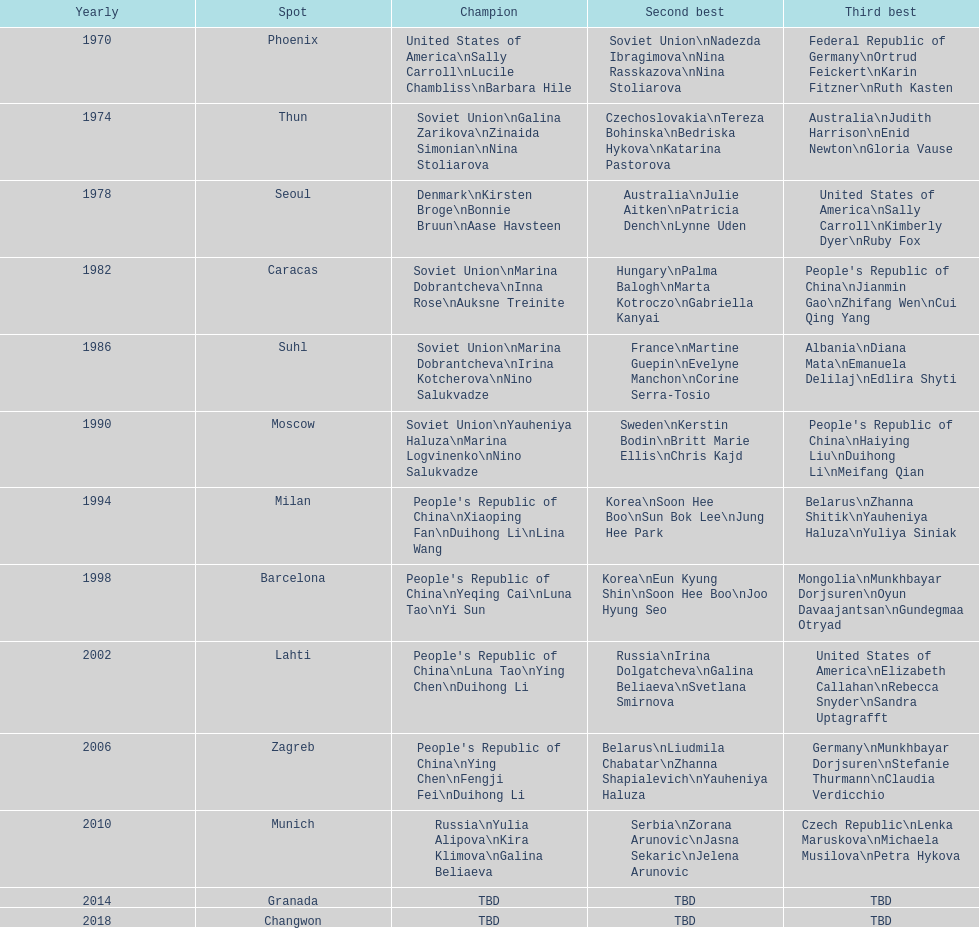How many world championships had the soviet union won first place in in the 25 metre pistol women's world championship? 4. 